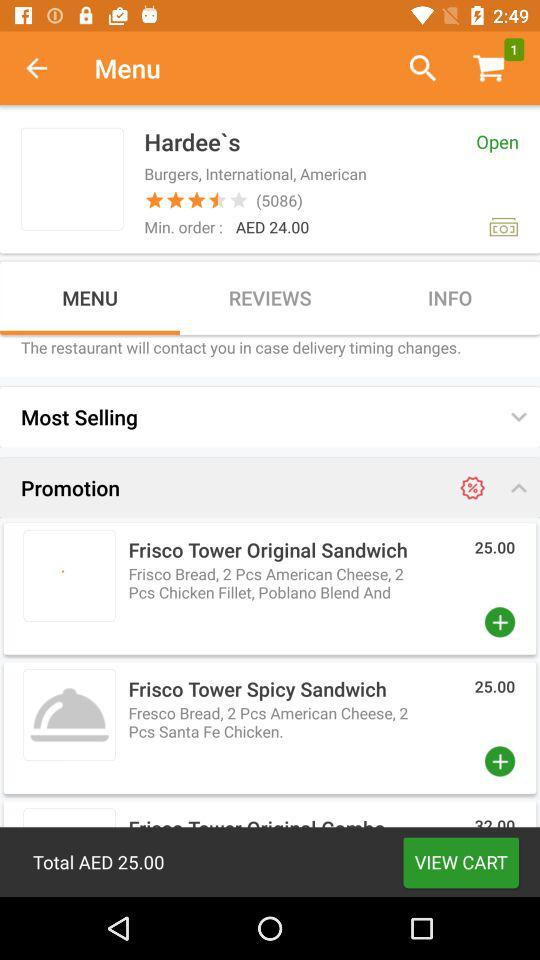What is the price of a "Frisco Tower Spicy Sandwich"? The price is 25. 